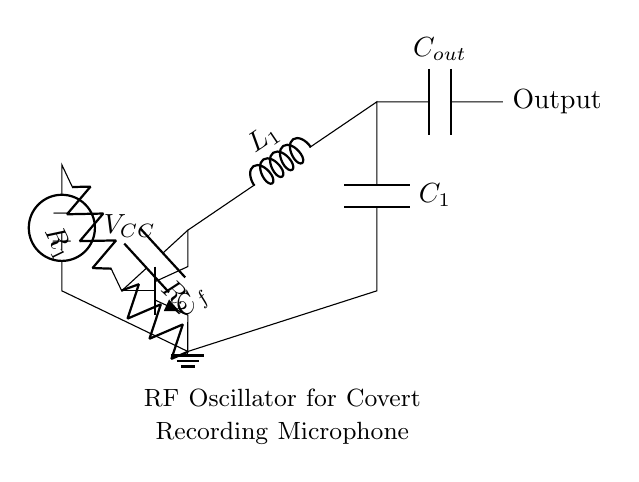What type of transistor is used in this circuit? The circuit diagram includes an npn transistor, which is indicated by the notation of the component labeled as "npn" in the diagram.
Answer: npn What are the values of the inductance and capacitance in the LC tank circuit? The LC tank circuit consists of an inductor labeled as L1 and a capacitor labeled as C1. The values of these components are not specified numerically in the diagram, but their identifiers indicate their function in the circuit.
Answer: L1, C1 How many resistors are present in the oscillator circuit? The circuit contains two resistors, labeled as R1 and R2, which connect the transistor base and emitter to the voltage source and the transistor, respectively.
Answer: 2 What is the purpose of capacitor C_f in this oscillator circuit? Capacitor C_f provides feedback from the collector to the base of the transistor, which is essential for sustaining oscillations. This feedback ensures that the transistor's operation remains stable and supports the oscillation process.
Answer: Feedback Which component is used to couple the output signal in the circuit? The output capacitive coupling is provided by capacitor C_out, which allows the AC oscillation to be transferred while blocking any DC offset at the output.
Answer: C_out What role does the voltage source V_CC play in the oscillator circuit? The voltage source V_CC provides the necessary biasing for the transistor, enabling it to operate in the active region and thereby facilitating oscillation. Its connection to the resistors supports appropriate voltage levels for the transistor.
Answer: Biasing What is the primary function of the LC tank circuit in this RF oscillator? The LC tank circuit is responsible for determining the oscillation frequency, as it forms a resonant circuit where the energy oscillates between the inductor and capacitor, creating a sustained RF signal.
Answer: Frequency determination 